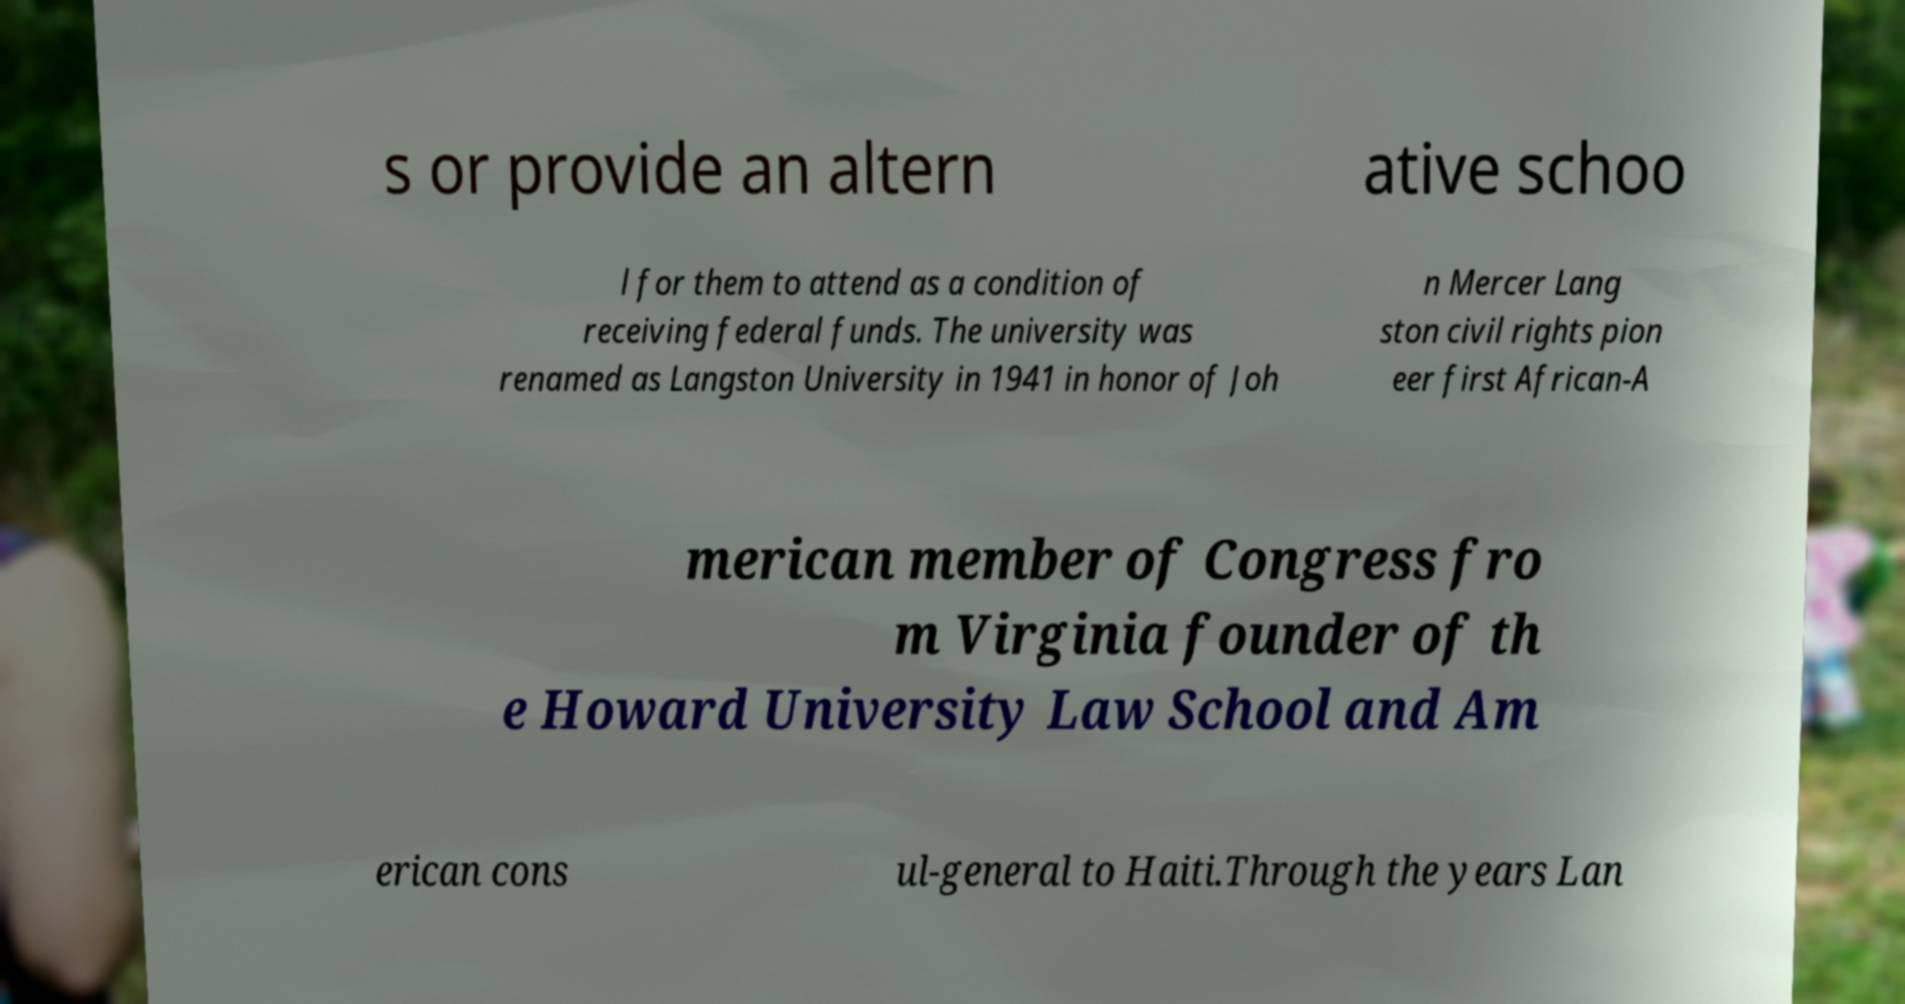Please read and relay the text visible in this image. What does it say? s or provide an altern ative schoo l for them to attend as a condition of receiving federal funds. The university was renamed as Langston University in 1941 in honor of Joh n Mercer Lang ston civil rights pion eer first African-A merican member of Congress fro m Virginia founder of th e Howard University Law School and Am erican cons ul-general to Haiti.Through the years Lan 